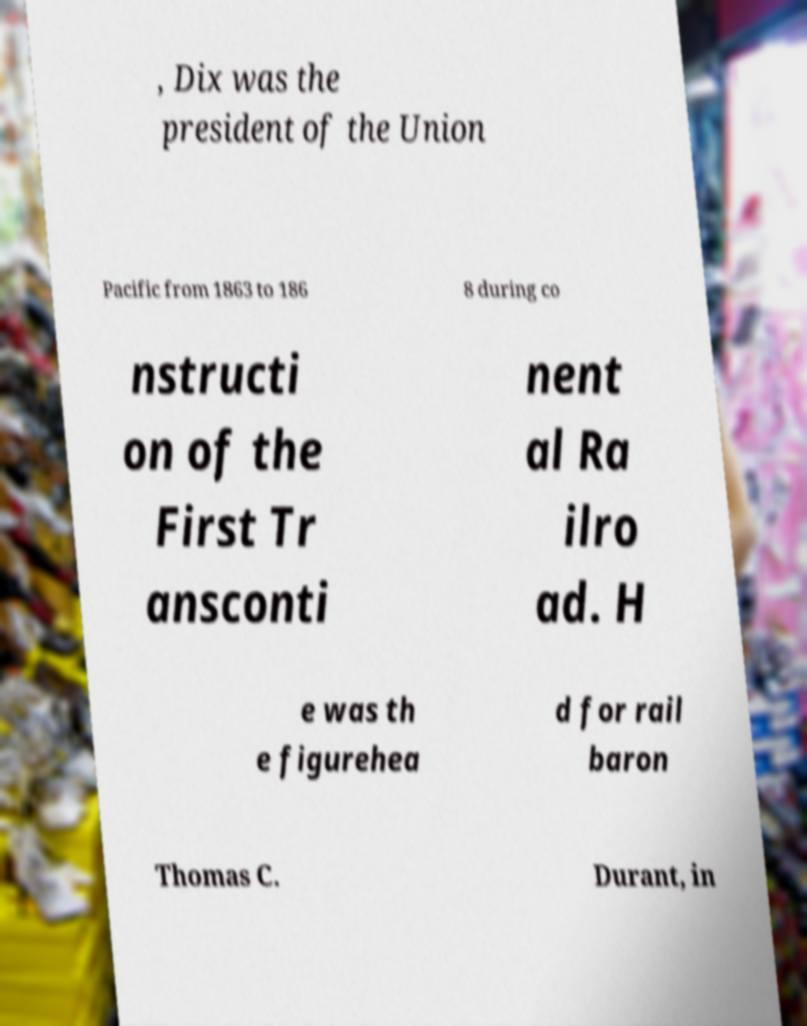I need the written content from this picture converted into text. Can you do that? , Dix was the president of the Union Pacific from 1863 to 186 8 during co nstructi on of the First Tr ansconti nent al Ra ilro ad. H e was th e figurehea d for rail baron Thomas C. Durant, in 